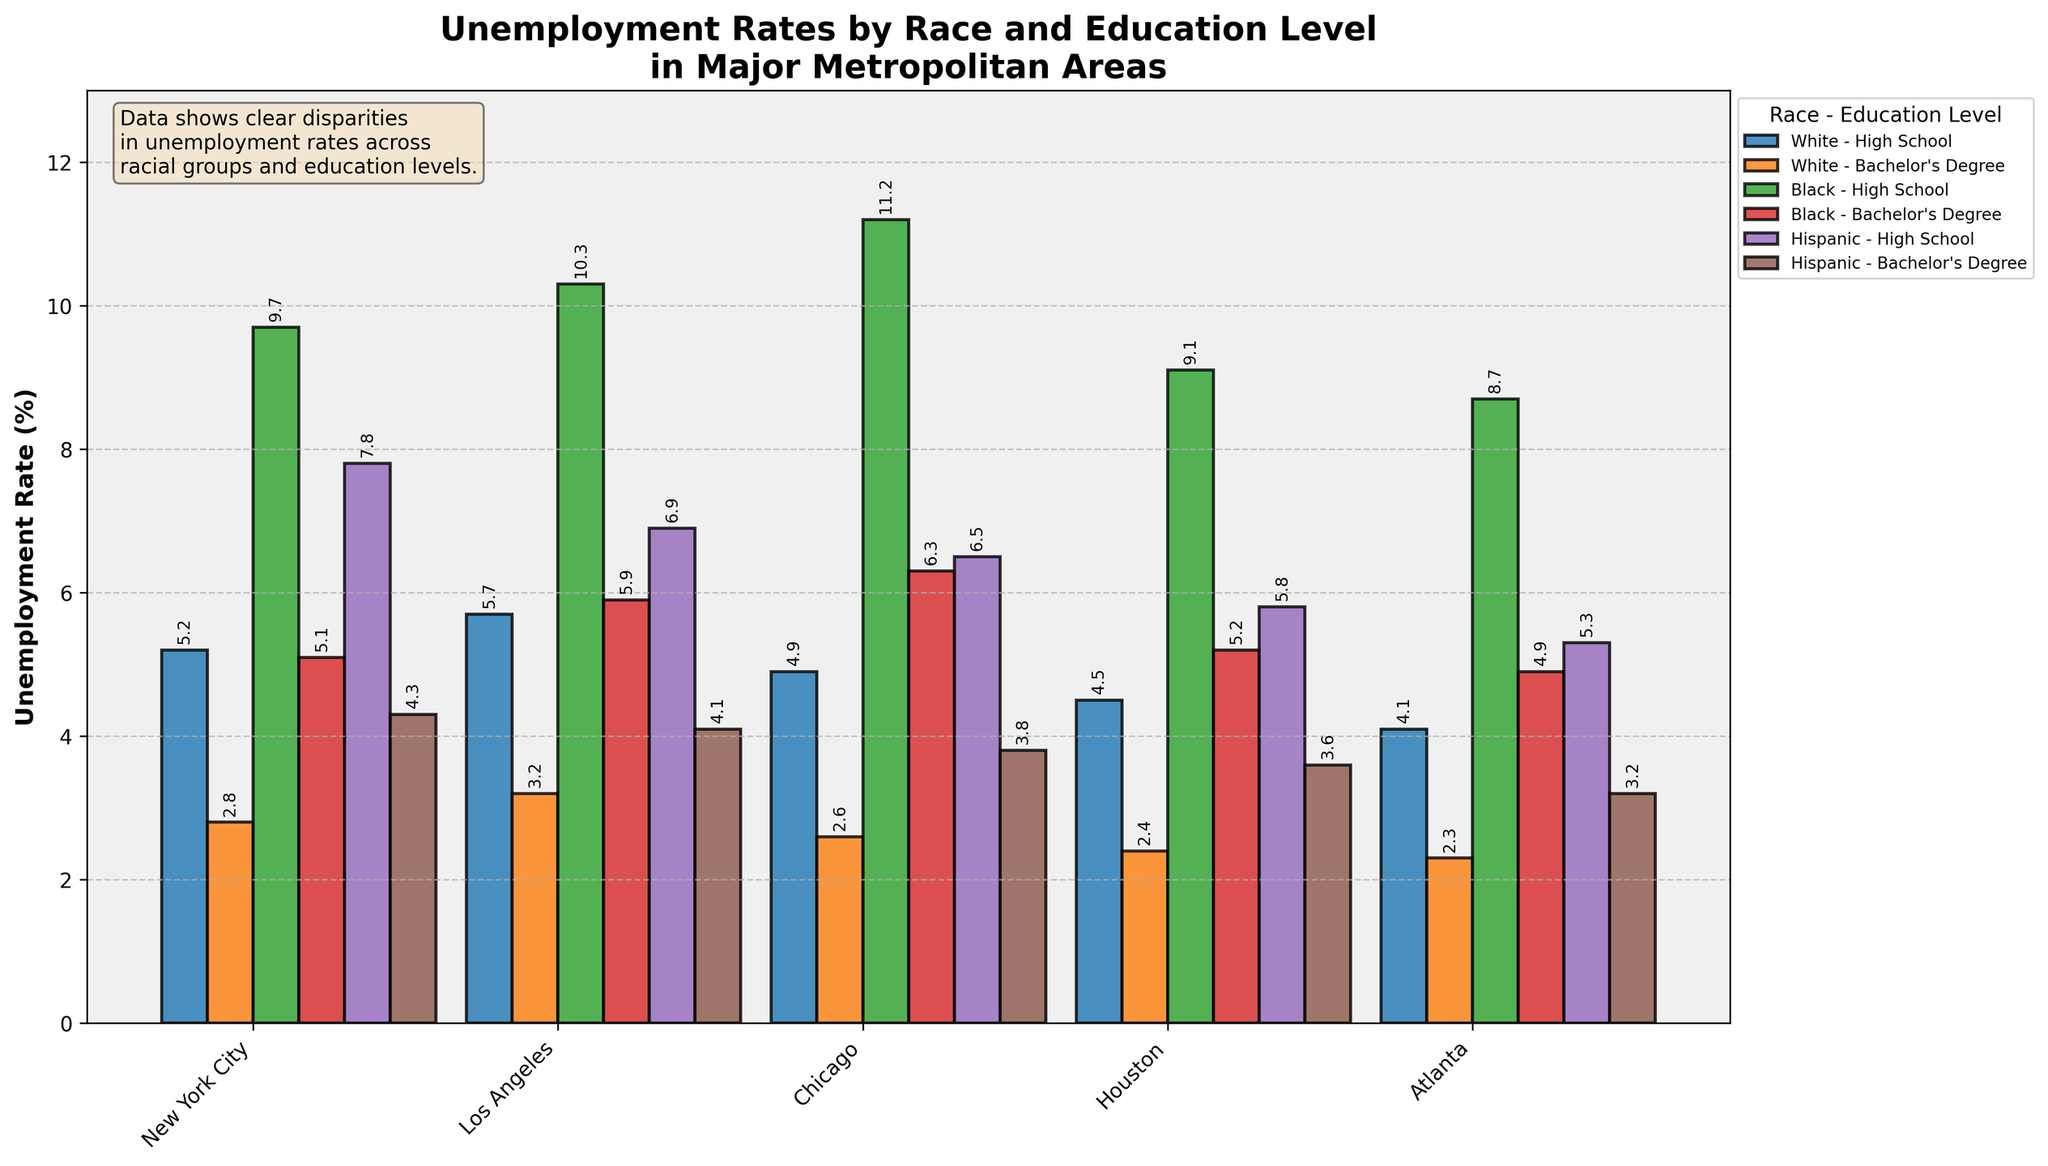Which metropolitan area has the highest unemployment rate for Black individuals with a high school education? Look at the bars representing Black individuals with a high school education and compare their heights across all metropolitan areas. Chicago has the highest bar for this group.
Answer: Chicago Comparing Black individuals with a high school education to White individuals with a high school education, which group has a higher unemployment rate in New York City? Refer to the bars for Black and White individuals with a high school education in New York City. The bar for Black individuals is higher than that for White individuals.
Answer: Black individuals What is the difference in unemployment rates between Hispanics with a high school education and Hispanics with a bachelor's degree in Houston? Look at the heights of the two bars representing Hispanic individuals with a high school education and those with a bachelor's degree in Houston. Subtract the bachelor's degree rate (3.6) from the high school rate (5.8).
Answer: 2.2 On average, do Hispanic individuals or White individuals face higher unemployment rates in Atlanta regardless of their education level? Calculate the average unemployment rate for Hispanic (5.3+3.2)/2 and White (4.1+2.3)/2 individuals in Atlanta. Compare the two averages.
Answer: Hispanic individuals Which group has the lowest unemployment rate among all groups and education levels in Los Angeles, and what is it? Identify the bars representing all groups and education levels in Los Angeles. The bar for White individuals with a bachelor's degree is the lowest.
Answer: White - Bachelor's Degree, 3.2 Which metropolitan area shows the smallest difference in unemployment rates between Black individuals with a high school education and with a bachelor's degree? Calculate the difference in unemployment rates for Black individuals with high school and bachelor's degrees for each metropolitan area. The difference is smallest in Atlanta (8.7 - 4.9 = 3.8).
Answer: Atlanta Comparing all groups in Chicago, who experiences the highest unemployment rate? Look at all the bars for Chicago; the highest one corresponds to Black individuals with a high school education.
Answer: Black individuals with High School education Which education level tends to show lower unemployment rates within each racial group across all metropolitan areas? Compare the bars representing individuals with a high school education to those with a bachelor's degree within each racial group. Typically, bars for those with bachelor's degrees are lower.
Answer: Bachelor's degree 